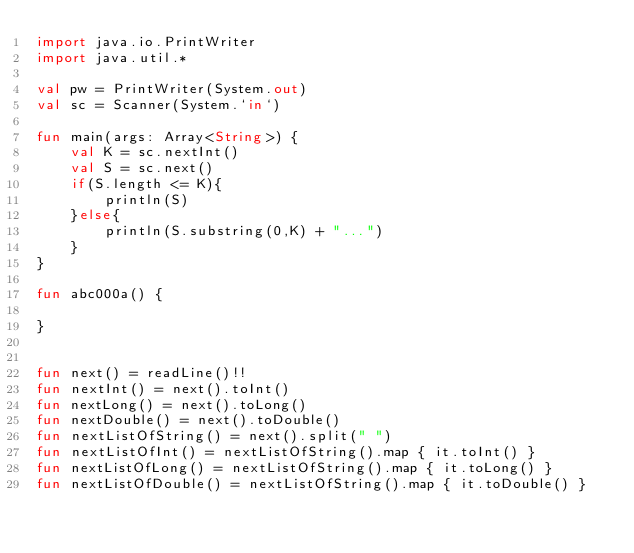Convert code to text. <code><loc_0><loc_0><loc_500><loc_500><_Kotlin_>import java.io.PrintWriter
import java.util.*

val pw = PrintWriter(System.out)
val sc = Scanner(System.`in`)

fun main(args: Array<String>) {
    val K = sc.nextInt()
    val S = sc.next()
    if(S.length <= K){
        println(S)
    }else{
        println(S.substring(0,K) + "...")
    }
}

fun abc000a() {

}


fun next() = readLine()!!
fun nextInt() = next().toInt()
fun nextLong() = next().toLong()
fun nextDouble() = next().toDouble()
fun nextListOfString() = next().split(" ")
fun nextListOfInt() = nextListOfString().map { it.toInt() }
fun nextListOfLong() = nextListOfString().map { it.toLong() }
fun nextListOfDouble() = nextListOfString().map { it.toDouble() }

</code> 